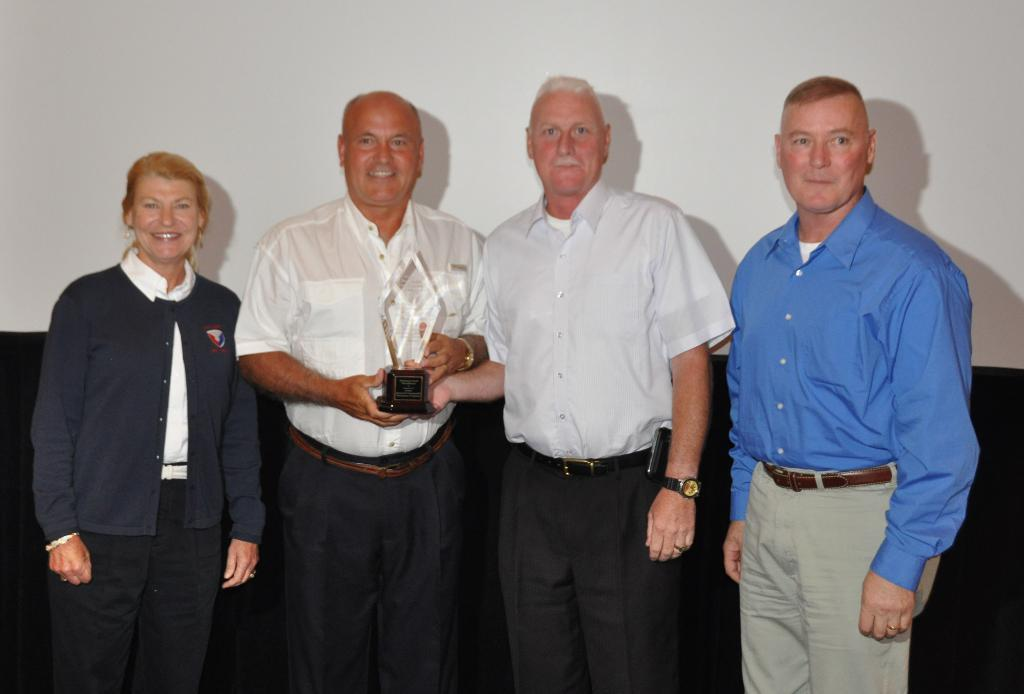Who or what is present in the image? There are people in the image. Where are the people located in the image? The people are in the center of the image. What are the people holding in their hands? The people are holding a trophy in their hands. What type of arch can be seen in the image? There is no arch present in the image. How many loaves of bread are visible in the image? There are no loaves of bread present in the image. 